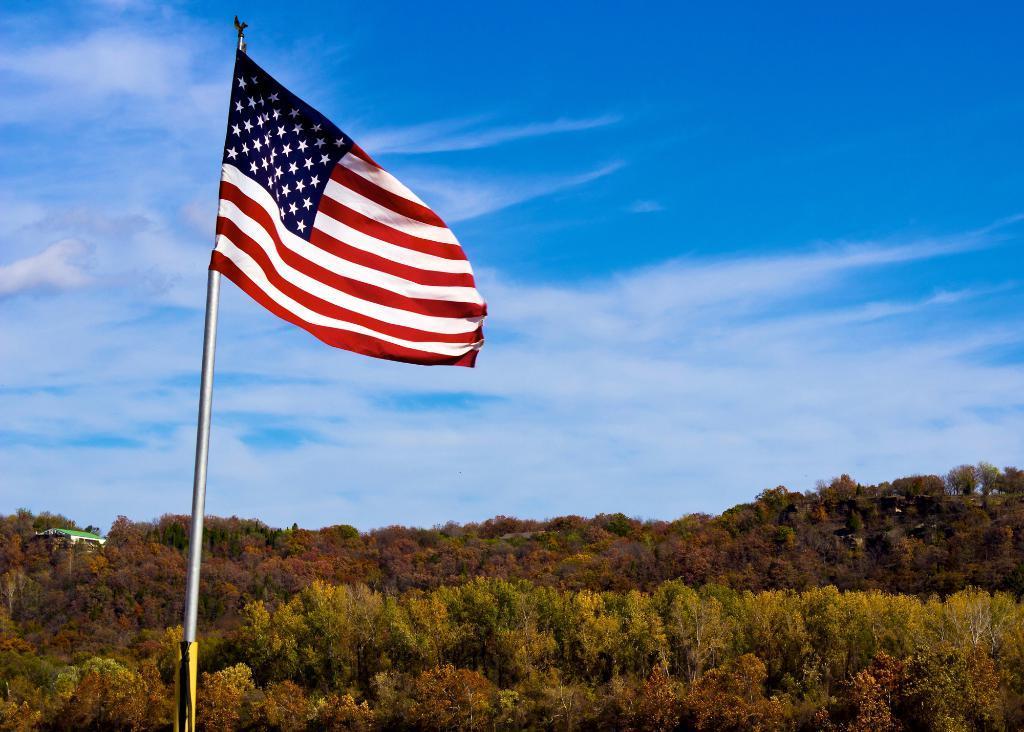How would you summarize this image in a sentence or two? In this picture there is an american flag on the left side of the image and there are trees at the bottom side of the image. 